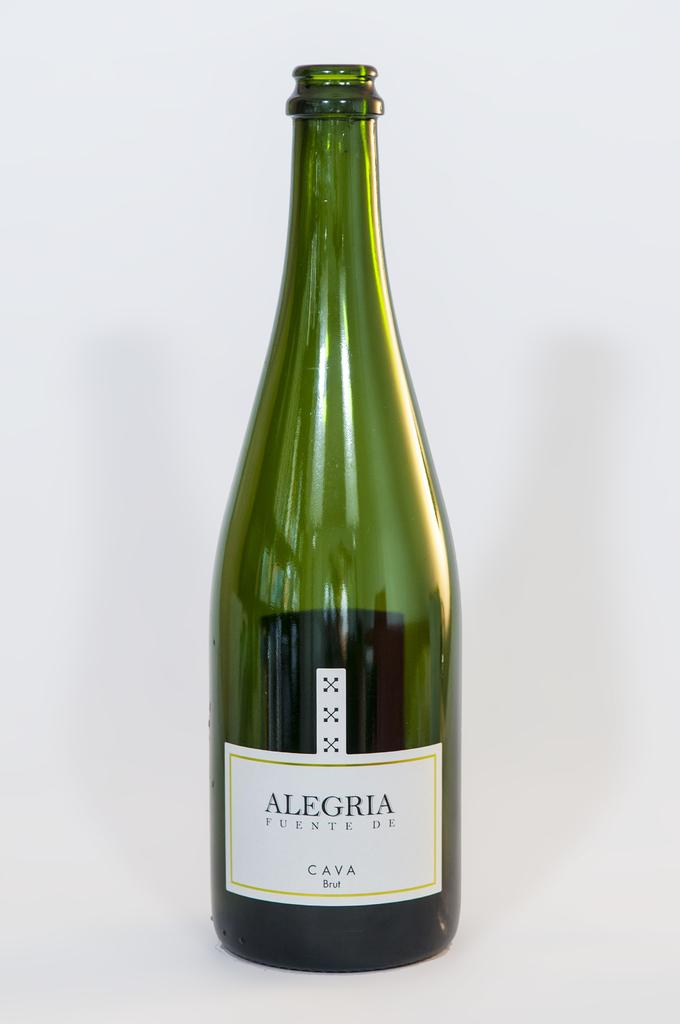<image>
Render a clear and concise summary of the photo. an empty bottle of Alegria cava on a white surface 